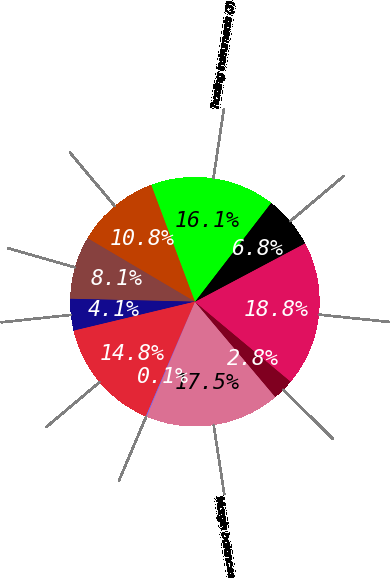Convert chart to OTSL. <chart><loc_0><loc_0><loc_500><loc_500><pie_chart><fcel>Margin balances<fcel>Assets segregated pursuant to<fcel>Bank loans net of unearned<fcel>Available for sale securities<fcel>Trading instruments (3)<fcel>Stock loan<fcel>Loans to financial advisors<fcel>Corporate cash and all other<fcel>Total<fcel>Brokerage client liabilities<nl><fcel>17.49%<fcel>2.78%<fcel>18.83%<fcel>6.79%<fcel>16.15%<fcel>10.8%<fcel>8.13%<fcel>4.11%<fcel>14.82%<fcel>0.1%<nl></chart> 